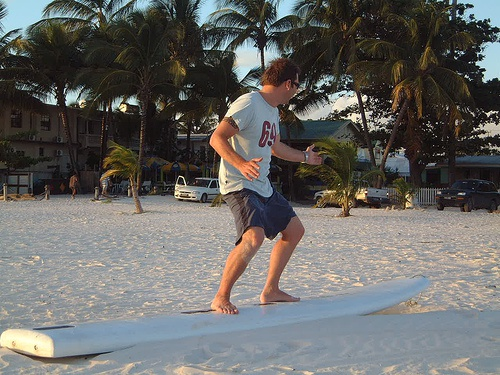Describe the objects in this image and their specific colors. I can see people in lightblue, gray, black, darkgray, and salmon tones, surfboard in lightblue, darkgray, gray, lightyellow, and khaki tones, car in lightblue, black, and gray tones, car in lightblue, black, gray, and darkgray tones, and car in lightblue, black, gray, tan, and olive tones in this image. 